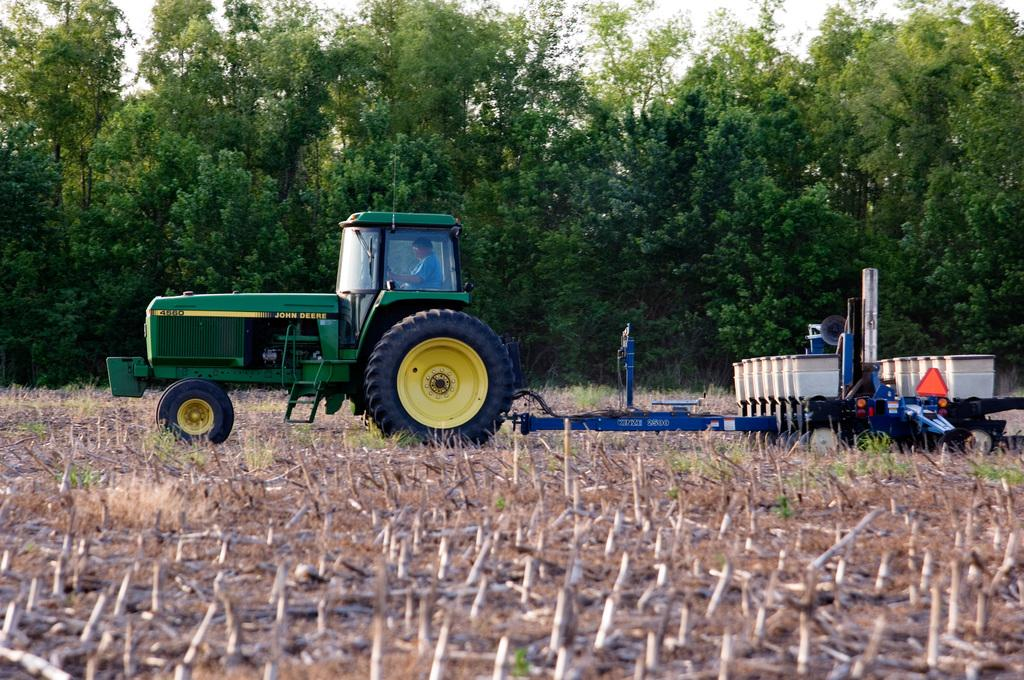What is the person in the image doing? There is a person inside a tractor in the image. What is the tractor's position in the image? The tractor is on the ground. What type of vegetation can be seen in the image? Grass is visible in the image. What else can be seen in the image besides the tractor and person? There are objects in the image. What is visible in the background of the image? There are trees in the background of the image. Reasoning: Let'ing: Let's think step by step in order to produce the conversation. We start by identifying the main subject in the image, which is the person inside the tractor. Then, we expand the conversation to include details about the tractor's position, the type of vegetation visible, and any other objects or features present in the image. We also mention the background of the image, which includes trees. Absurd Question/Answer: What type of magic is being performed by the person inside the tractor? There is no magic being performed in the image; it simply shows a person inside a tractor. How many ears can be seen on the person inside the tractor? The image does not show the person's ears, so it cannot be determined how many ears they have. 